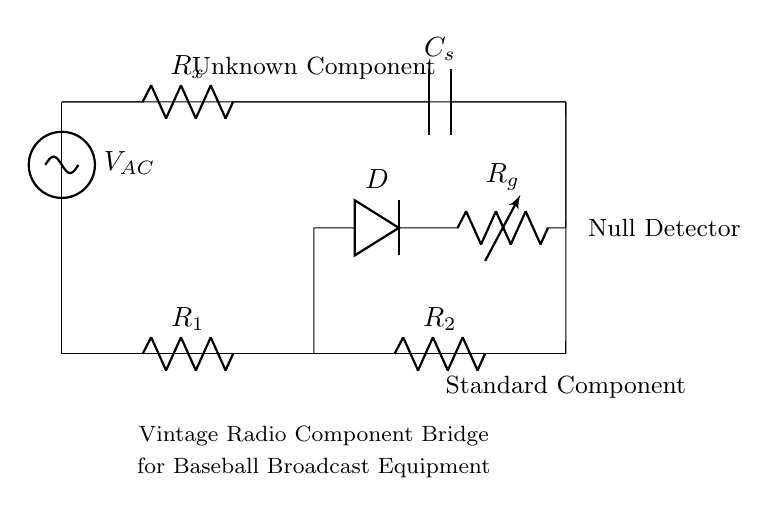What is the type of voltage used in this circuit? The circuit uses alternating current voltage, indicated by the label V_AC in the diagram.
Answer: AC What does R_x represent in this circuit? R_x represents the unknown component being tested in the bridge circuit labeled as "Unknown Component."
Answer: Unknown Component How many resistors are present in the circuit? There are three resistors: R_1, R_2, and R_x, as indicated in the diagram.
Answer: Three What is the function of the diode in the circuit? The diode, labeled D, allows current to flow in one direction, which is necessary for the null detection in this bridge setup.
Answer: Null detection Why is a null detector included in this bridge circuit? The null detector is included to identify the balance point in the bridge, indicating when the unknown component's impedance matches that of the known components.
Answer: Balance point What does C_s indicate in the bridge circuit? C_s indicates a capacitor in the circuit, specifically used as part of the bridge configuration to balance the impedance.
Answer: Capacitor What components are compared in this bridge? The components compared are the unknown component (R_x) and the known standard component (R_2).
Answer: Unknown and standard components 